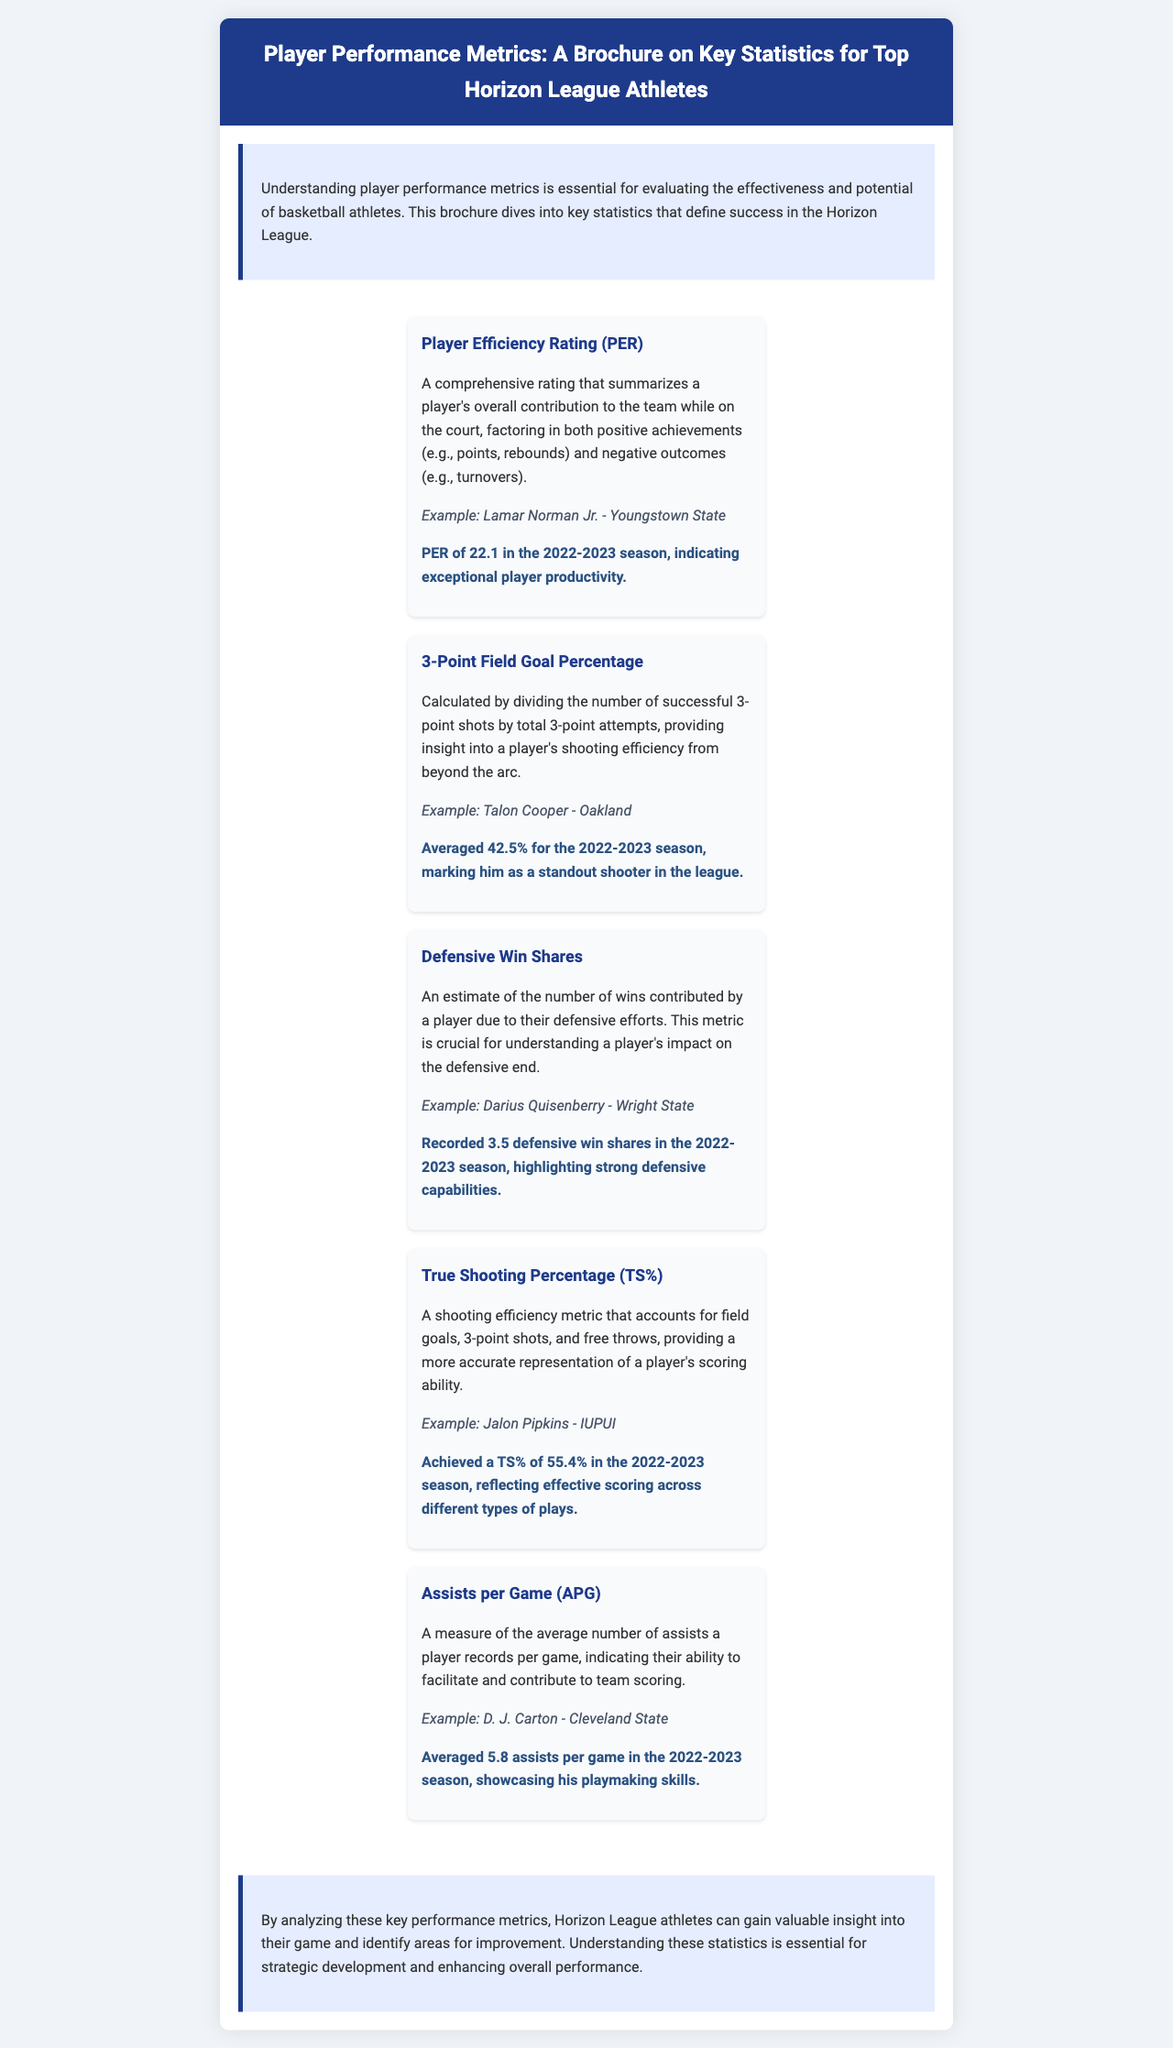what is the title of the brochure? The title of the brochure is presented in the header section, which provides a clear overview of its content.
Answer: Player Performance Metrics: A Brochure on Key Statistics for Top Horizon League Athletes who had a Player Efficiency Rating of 22.1? The document specifically mentions this statistic and the player associated with it.
Answer: Lamar Norman Jr. - Youngstown State what percentage did Talon Cooper average for 3-Point Field Goals? This information is found in the metric section discussing shooting efficiency beyond the arc.
Answer: 42.5% how many Defensive Win Shares did Darius Quisenberry record? The metric related to defensive contributions details this player’s defensive impact.
Answer: 3.5 which player averaged 5.8 assists per game? This statistic highlights a player's playmaking ability, as described in the assists subsection.
Answer: D. J. Carton - Cleveland State what does TS% stand for in the context of the brochure? This abbreviation is used in the shooting efficiency discussion, indicating a specific metric.
Answer: True Shooting Percentage which player's example is given in the context of assists per game? The document provides a specific example to illustrate this metric.
Answer: D. J. Carton - Cleveland State what is the primary focus of the introductory paragraph? The introduction outlines the essential role of metrics in evaluating athletes' performances.
Answer: Understanding player performance metrics who was noted for strong defensive capabilities? The defensive win shares section points out this player's contributions on defense.
Answer: Darius Quisenberry - Wright State 